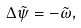Convert formula to latex. <formula><loc_0><loc_0><loc_500><loc_500>\Delta \tilde { \psi } = - \tilde { \omega } ,</formula> 